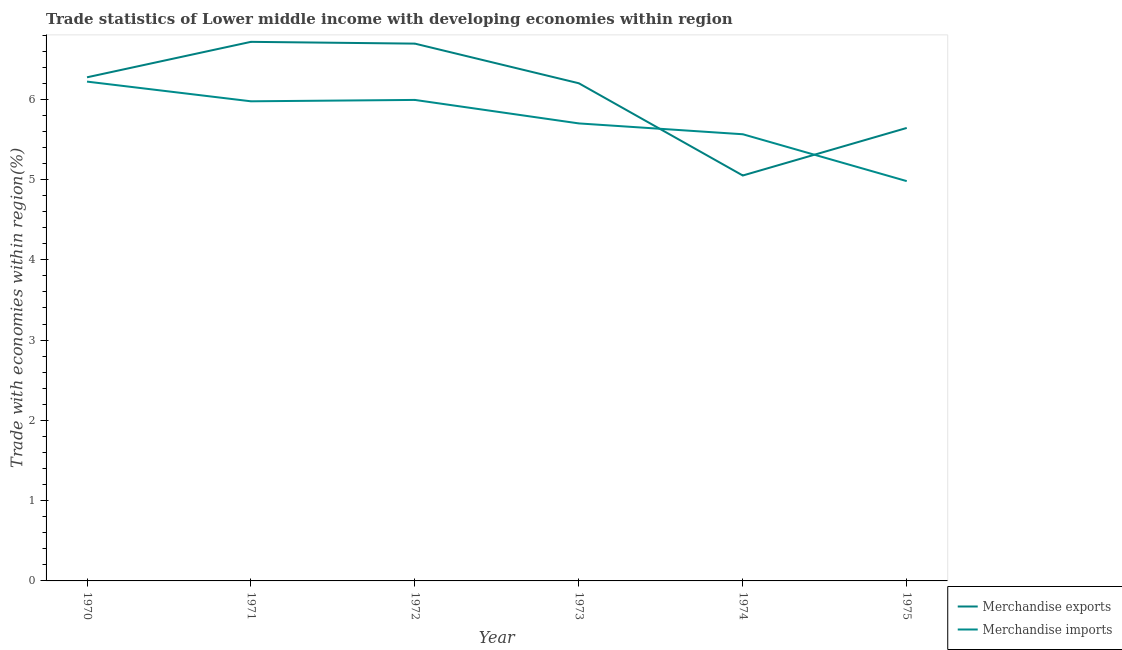How many different coloured lines are there?
Offer a very short reply. 2. What is the merchandise imports in 1971?
Make the answer very short. 5.97. Across all years, what is the maximum merchandise imports?
Your answer should be very brief. 6.22. Across all years, what is the minimum merchandise exports?
Give a very brief answer. 5.05. In which year was the merchandise imports minimum?
Your answer should be very brief. 1975. What is the total merchandise exports in the graph?
Offer a terse response. 36.57. What is the difference between the merchandise exports in 1972 and that in 1975?
Your answer should be very brief. 1.05. What is the difference between the merchandise imports in 1972 and the merchandise exports in 1973?
Make the answer very short. -0.21. What is the average merchandise imports per year?
Keep it short and to the point. 5.74. In the year 1972, what is the difference between the merchandise imports and merchandise exports?
Your answer should be very brief. -0.7. What is the ratio of the merchandise exports in 1971 to that in 1975?
Offer a terse response. 1.19. What is the difference between the highest and the second highest merchandise imports?
Keep it short and to the point. 0.23. What is the difference between the highest and the lowest merchandise imports?
Your answer should be very brief. 1.24. Does the merchandise imports monotonically increase over the years?
Give a very brief answer. No. Is the merchandise exports strictly greater than the merchandise imports over the years?
Give a very brief answer. No. Is the merchandise imports strictly less than the merchandise exports over the years?
Ensure brevity in your answer.  No. What is the difference between two consecutive major ticks on the Y-axis?
Make the answer very short. 1. Are the values on the major ticks of Y-axis written in scientific E-notation?
Your answer should be compact. No. Does the graph contain any zero values?
Your answer should be very brief. No. How many legend labels are there?
Give a very brief answer. 2. What is the title of the graph?
Offer a very short reply. Trade statistics of Lower middle income with developing economies within region. What is the label or title of the Y-axis?
Your response must be concise. Trade with economies within region(%). What is the Trade with economies within region(%) in Merchandise exports in 1970?
Your answer should be very brief. 6.27. What is the Trade with economies within region(%) of Merchandise imports in 1970?
Offer a terse response. 6.22. What is the Trade with economies within region(%) in Merchandise exports in 1971?
Make the answer very short. 6.72. What is the Trade with economies within region(%) in Merchandise imports in 1971?
Your answer should be compact. 5.97. What is the Trade with economies within region(%) of Merchandise exports in 1972?
Provide a succinct answer. 6.69. What is the Trade with economies within region(%) of Merchandise imports in 1972?
Your answer should be compact. 5.99. What is the Trade with economies within region(%) of Merchandise exports in 1973?
Keep it short and to the point. 6.2. What is the Trade with economies within region(%) in Merchandise imports in 1973?
Provide a succinct answer. 5.7. What is the Trade with economies within region(%) of Merchandise exports in 1974?
Offer a very short reply. 5.05. What is the Trade with economies within region(%) of Merchandise imports in 1974?
Give a very brief answer. 5.56. What is the Trade with economies within region(%) of Merchandise exports in 1975?
Keep it short and to the point. 5.64. What is the Trade with economies within region(%) in Merchandise imports in 1975?
Your answer should be compact. 4.98. Across all years, what is the maximum Trade with economies within region(%) of Merchandise exports?
Provide a short and direct response. 6.72. Across all years, what is the maximum Trade with economies within region(%) in Merchandise imports?
Your response must be concise. 6.22. Across all years, what is the minimum Trade with economies within region(%) in Merchandise exports?
Ensure brevity in your answer.  5.05. Across all years, what is the minimum Trade with economies within region(%) of Merchandise imports?
Give a very brief answer. 4.98. What is the total Trade with economies within region(%) in Merchandise exports in the graph?
Your answer should be compact. 36.57. What is the total Trade with economies within region(%) in Merchandise imports in the graph?
Offer a terse response. 34.43. What is the difference between the Trade with economies within region(%) in Merchandise exports in 1970 and that in 1971?
Offer a very short reply. -0.44. What is the difference between the Trade with economies within region(%) in Merchandise imports in 1970 and that in 1971?
Provide a short and direct response. 0.25. What is the difference between the Trade with economies within region(%) in Merchandise exports in 1970 and that in 1972?
Your response must be concise. -0.42. What is the difference between the Trade with economies within region(%) in Merchandise imports in 1970 and that in 1972?
Give a very brief answer. 0.23. What is the difference between the Trade with economies within region(%) in Merchandise exports in 1970 and that in 1973?
Offer a terse response. 0.07. What is the difference between the Trade with economies within region(%) of Merchandise imports in 1970 and that in 1973?
Your answer should be very brief. 0.52. What is the difference between the Trade with economies within region(%) of Merchandise exports in 1970 and that in 1974?
Your answer should be very brief. 1.22. What is the difference between the Trade with economies within region(%) in Merchandise imports in 1970 and that in 1974?
Provide a succinct answer. 0.66. What is the difference between the Trade with economies within region(%) of Merchandise exports in 1970 and that in 1975?
Provide a short and direct response. 0.63. What is the difference between the Trade with economies within region(%) of Merchandise imports in 1970 and that in 1975?
Provide a succinct answer. 1.24. What is the difference between the Trade with economies within region(%) in Merchandise exports in 1971 and that in 1972?
Your answer should be compact. 0.02. What is the difference between the Trade with economies within region(%) in Merchandise imports in 1971 and that in 1972?
Provide a short and direct response. -0.02. What is the difference between the Trade with economies within region(%) in Merchandise exports in 1971 and that in 1973?
Ensure brevity in your answer.  0.52. What is the difference between the Trade with economies within region(%) of Merchandise imports in 1971 and that in 1973?
Keep it short and to the point. 0.28. What is the difference between the Trade with economies within region(%) in Merchandise exports in 1971 and that in 1974?
Ensure brevity in your answer.  1.67. What is the difference between the Trade with economies within region(%) in Merchandise imports in 1971 and that in 1974?
Offer a very short reply. 0.41. What is the difference between the Trade with economies within region(%) of Merchandise exports in 1971 and that in 1975?
Offer a very short reply. 1.07. What is the difference between the Trade with economies within region(%) of Merchandise imports in 1971 and that in 1975?
Make the answer very short. 0.99. What is the difference between the Trade with economies within region(%) in Merchandise exports in 1972 and that in 1973?
Make the answer very short. 0.49. What is the difference between the Trade with economies within region(%) in Merchandise imports in 1972 and that in 1973?
Offer a very short reply. 0.29. What is the difference between the Trade with economies within region(%) of Merchandise exports in 1972 and that in 1974?
Offer a very short reply. 1.64. What is the difference between the Trade with economies within region(%) in Merchandise imports in 1972 and that in 1974?
Ensure brevity in your answer.  0.43. What is the difference between the Trade with economies within region(%) of Merchandise exports in 1972 and that in 1975?
Keep it short and to the point. 1.05. What is the difference between the Trade with economies within region(%) in Merchandise imports in 1972 and that in 1975?
Give a very brief answer. 1.01. What is the difference between the Trade with economies within region(%) in Merchandise exports in 1973 and that in 1974?
Your answer should be compact. 1.15. What is the difference between the Trade with economies within region(%) in Merchandise imports in 1973 and that in 1974?
Provide a short and direct response. 0.13. What is the difference between the Trade with economies within region(%) in Merchandise exports in 1973 and that in 1975?
Provide a succinct answer. 0.56. What is the difference between the Trade with economies within region(%) in Merchandise imports in 1973 and that in 1975?
Offer a very short reply. 0.72. What is the difference between the Trade with economies within region(%) of Merchandise exports in 1974 and that in 1975?
Your answer should be compact. -0.59. What is the difference between the Trade with economies within region(%) in Merchandise imports in 1974 and that in 1975?
Make the answer very short. 0.58. What is the difference between the Trade with economies within region(%) of Merchandise exports in 1970 and the Trade with economies within region(%) of Merchandise imports in 1971?
Provide a succinct answer. 0.3. What is the difference between the Trade with economies within region(%) of Merchandise exports in 1970 and the Trade with economies within region(%) of Merchandise imports in 1972?
Make the answer very short. 0.28. What is the difference between the Trade with economies within region(%) in Merchandise exports in 1970 and the Trade with economies within region(%) in Merchandise imports in 1973?
Offer a terse response. 0.57. What is the difference between the Trade with economies within region(%) in Merchandise exports in 1970 and the Trade with economies within region(%) in Merchandise imports in 1974?
Your answer should be very brief. 0.71. What is the difference between the Trade with economies within region(%) in Merchandise exports in 1970 and the Trade with economies within region(%) in Merchandise imports in 1975?
Your answer should be compact. 1.29. What is the difference between the Trade with economies within region(%) of Merchandise exports in 1971 and the Trade with economies within region(%) of Merchandise imports in 1972?
Provide a succinct answer. 0.72. What is the difference between the Trade with economies within region(%) of Merchandise exports in 1971 and the Trade with economies within region(%) of Merchandise imports in 1973?
Your answer should be compact. 1.02. What is the difference between the Trade with economies within region(%) in Merchandise exports in 1971 and the Trade with economies within region(%) in Merchandise imports in 1974?
Give a very brief answer. 1.15. What is the difference between the Trade with economies within region(%) in Merchandise exports in 1971 and the Trade with economies within region(%) in Merchandise imports in 1975?
Provide a short and direct response. 1.74. What is the difference between the Trade with economies within region(%) of Merchandise exports in 1972 and the Trade with economies within region(%) of Merchandise imports in 1973?
Keep it short and to the point. 0.99. What is the difference between the Trade with economies within region(%) in Merchandise exports in 1972 and the Trade with economies within region(%) in Merchandise imports in 1974?
Your response must be concise. 1.13. What is the difference between the Trade with economies within region(%) of Merchandise exports in 1972 and the Trade with economies within region(%) of Merchandise imports in 1975?
Make the answer very short. 1.71. What is the difference between the Trade with economies within region(%) of Merchandise exports in 1973 and the Trade with economies within region(%) of Merchandise imports in 1974?
Ensure brevity in your answer.  0.64. What is the difference between the Trade with economies within region(%) of Merchandise exports in 1973 and the Trade with economies within region(%) of Merchandise imports in 1975?
Your answer should be very brief. 1.22. What is the difference between the Trade with economies within region(%) of Merchandise exports in 1974 and the Trade with economies within region(%) of Merchandise imports in 1975?
Your response must be concise. 0.07. What is the average Trade with economies within region(%) of Merchandise exports per year?
Provide a short and direct response. 6.1. What is the average Trade with economies within region(%) of Merchandise imports per year?
Give a very brief answer. 5.74. In the year 1970, what is the difference between the Trade with economies within region(%) of Merchandise exports and Trade with economies within region(%) of Merchandise imports?
Provide a short and direct response. 0.05. In the year 1971, what is the difference between the Trade with economies within region(%) in Merchandise exports and Trade with economies within region(%) in Merchandise imports?
Your answer should be very brief. 0.74. In the year 1972, what is the difference between the Trade with economies within region(%) in Merchandise exports and Trade with economies within region(%) in Merchandise imports?
Keep it short and to the point. 0.7. In the year 1973, what is the difference between the Trade with economies within region(%) in Merchandise exports and Trade with economies within region(%) in Merchandise imports?
Provide a short and direct response. 0.5. In the year 1974, what is the difference between the Trade with economies within region(%) of Merchandise exports and Trade with economies within region(%) of Merchandise imports?
Keep it short and to the point. -0.51. In the year 1975, what is the difference between the Trade with economies within region(%) of Merchandise exports and Trade with economies within region(%) of Merchandise imports?
Provide a succinct answer. 0.66. What is the ratio of the Trade with economies within region(%) in Merchandise exports in 1970 to that in 1971?
Provide a short and direct response. 0.93. What is the ratio of the Trade with economies within region(%) of Merchandise imports in 1970 to that in 1971?
Offer a very short reply. 1.04. What is the ratio of the Trade with economies within region(%) of Merchandise exports in 1970 to that in 1972?
Provide a succinct answer. 0.94. What is the ratio of the Trade with economies within region(%) of Merchandise imports in 1970 to that in 1972?
Your response must be concise. 1.04. What is the ratio of the Trade with economies within region(%) of Merchandise imports in 1970 to that in 1973?
Offer a terse response. 1.09. What is the ratio of the Trade with economies within region(%) of Merchandise exports in 1970 to that in 1974?
Offer a very short reply. 1.24. What is the ratio of the Trade with economies within region(%) in Merchandise imports in 1970 to that in 1974?
Offer a terse response. 1.12. What is the ratio of the Trade with economies within region(%) of Merchandise exports in 1970 to that in 1975?
Provide a succinct answer. 1.11. What is the ratio of the Trade with economies within region(%) in Merchandise imports in 1970 to that in 1975?
Provide a short and direct response. 1.25. What is the ratio of the Trade with economies within region(%) in Merchandise exports in 1971 to that in 1973?
Your answer should be very brief. 1.08. What is the ratio of the Trade with economies within region(%) in Merchandise imports in 1971 to that in 1973?
Your answer should be compact. 1.05. What is the ratio of the Trade with economies within region(%) in Merchandise exports in 1971 to that in 1974?
Provide a succinct answer. 1.33. What is the ratio of the Trade with economies within region(%) of Merchandise imports in 1971 to that in 1974?
Offer a very short reply. 1.07. What is the ratio of the Trade with economies within region(%) of Merchandise exports in 1971 to that in 1975?
Your answer should be compact. 1.19. What is the ratio of the Trade with economies within region(%) of Merchandise imports in 1971 to that in 1975?
Provide a succinct answer. 1.2. What is the ratio of the Trade with economies within region(%) of Merchandise exports in 1972 to that in 1973?
Your answer should be compact. 1.08. What is the ratio of the Trade with economies within region(%) in Merchandise imports in 1972 to that in 1973?
Offer a terse response. 1.05. What is the ratio of the Trade with economies within region(%) in Merchandise exports in 1972 to that in 1974?
Your answer should be compact. 1.33. What is the ratio of the Trade with economies within region(%) in Merchandise imports in 1972 to that in 1974?
Provide a short and direct response. 1.08. What is the ratio of the Trade with economies within region(%) of Merchandise exports in 1972 to that in 1975?
Provide a short and direct response. 1.19. What is the ratio of the Trade with economies within region(%) in Merchandise imports in 1972 to that in 1975?
Provide a succinct answer. 1.2. What is the ratio of the Trade with economies within region(%) in Merchandise exports in 1973 to that in 1974?
Your answer should be very brief. 1.23. What is the ratio of the Trade with economies within region(%) in Merchandise imports in 1973 to that in 1974?
Your answer should be compact. 1.02. What is the ratio of the Trade with economies within region(%) in Merchandise exports in 1973 to that in 1975?
Give a very brief answer. 1.1. What is the ratio of the Trade with economies within region(%) in Merchandise imports in 1973 to that in 1975?
Offer a very short reply. 1.14. What is the ratio of the Trade with economies within region(%) in Merchandise exports in 1974 to that in 1975?
Your answer should be compact. 0.9. What is the ratio of the Trade with economies within region(%) of Merchandise imports in 1974 to that in 1975?
Provide a short and direct response. 1.12. What is the difference between the highest and the second highest Trade with economies within region(%) of Merchandise exports?
Your answer should be compact. 0.02. What is the difference between the highest and the second highest Trade with economies within region(%) in Merchandise imports?
Your answer should be compact. 0.23. What is the difference between the highest and the lowest Trade with economies within region(%) of Merchandise exports?
Your answer should be compact. 1.67. What is the difference between the highest and the lowest Trade with economies within region(%) in Merchandise imports?
Keep it short and to the point. 1.24. 